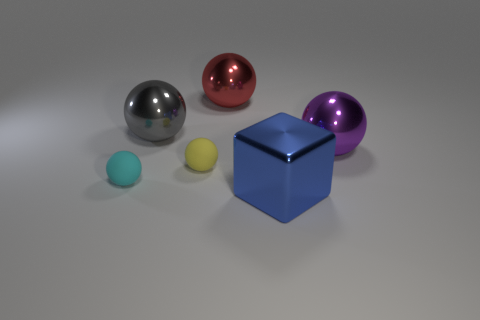Add 1 big blue metal things. How many objects exist? 7 Subtract all tiny yellow matte balls. How many balls are left? 4 Subtract all cyan spheres. How many spheres are left? 4 Subtract 2 balls. How many balls are left? 3 Subtract all blocks. How many objects are left? 5 Subtract all purple spheres. Subtract all brown blocks. How many spheres are left? 4 Subtract 0 green balls. How many objects are left? 6 Subtract all tiny yellow objects. Subtract all small cyan rubber objects. How many objects are left? 4 Add 1 yellow rubber objects. How many yellow rubber objects are left? 2 Add 5 large matte cylinders. How many large matte cylinders exist? 5 